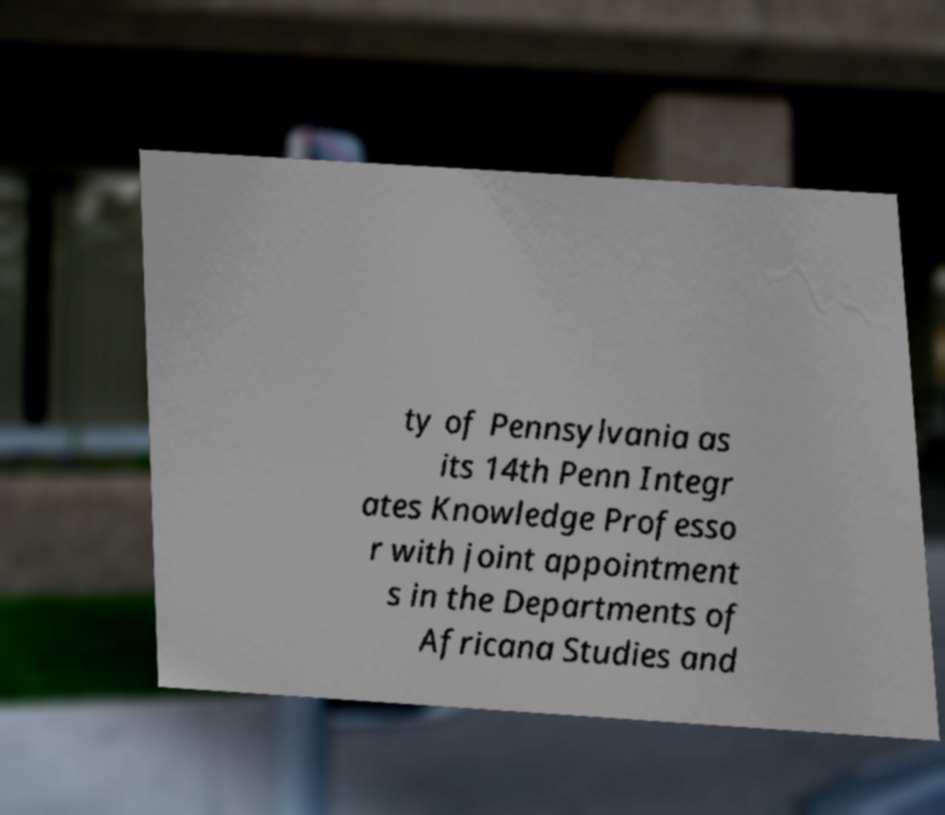Please read and relay the text visible in this image. What does it say? ty of Pennsylvania as its 14th Penn Integr ates Knowledge Professo r with joint appointment s in the Departments of Africana Studies and 